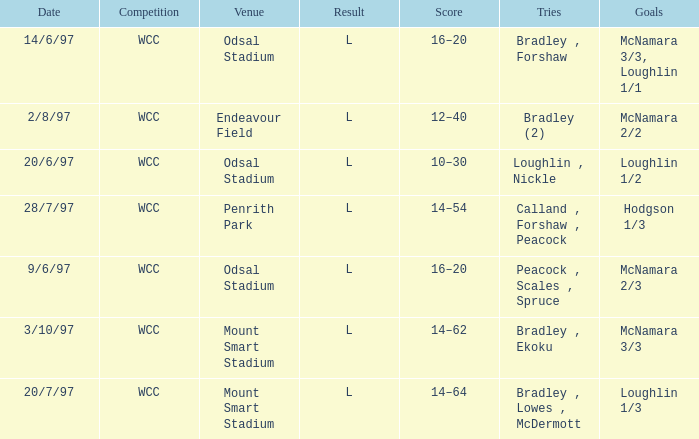What were the goals on 3/10/97? McNamara 3/3. 